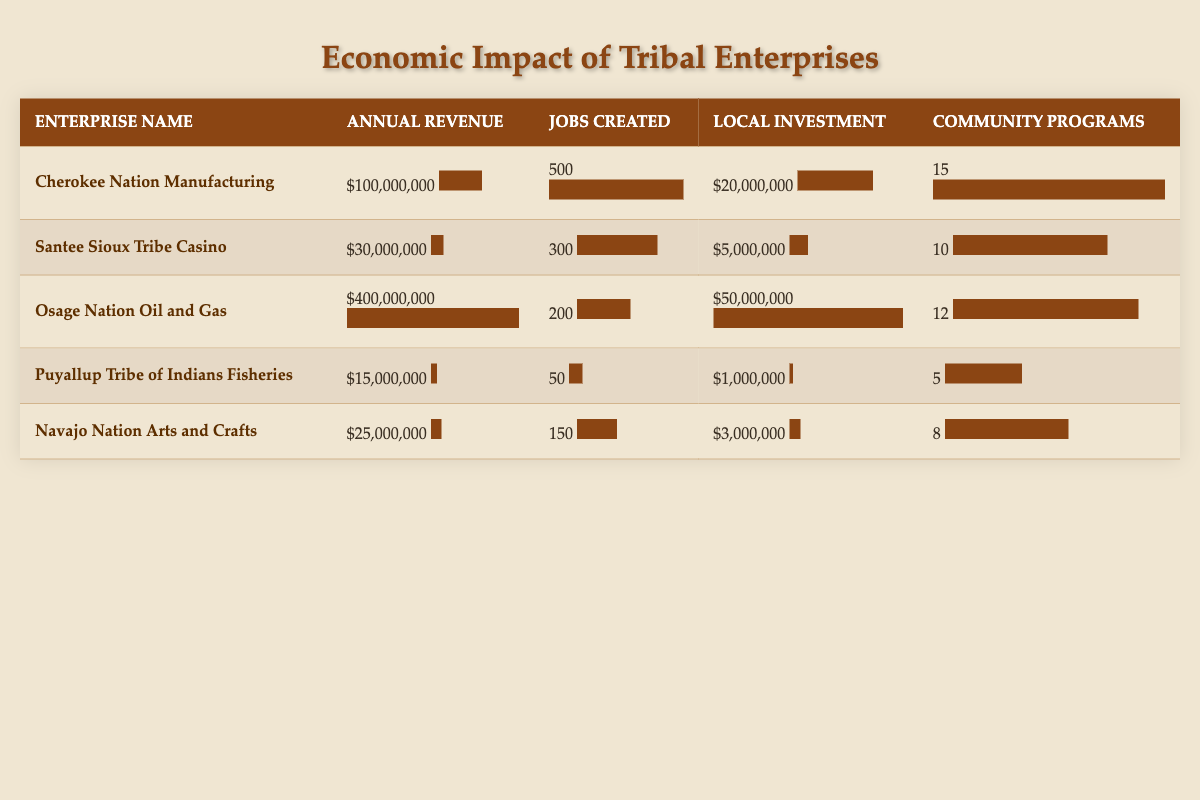What is the annual revenue of the Osage Nation Oil and Gas? The table shows that the annual revenue for the Osage Nation Oil and Gas is clearly listed as $400,000,000.
Answer: $400,000,000 How many jobs were created by the Cherokee Nation Manufacturing? Referring to the table, the number of jobs created by the Cherokee Nation Manufacturing is indicated as 500.
Answer: 500 Which tribal enterprise had the highest local investment? By examining the local investment values in the table, we see that the Osage Nation Oil and Gas has the highest local investment of $50,000,000.
Answer: Osage Nation Oil and Gas What is the total annual revenue generated by the Navajo Nation Arts and Crafts and the Puyallup Tribe of Indians Fisheries combined? To find the combined annual revenue, we add the annual revenues: $25,000,000 (Navajo Nation Arts and Crafts) + $15,000,000 (Puyallup Tribe of Indians Fisheries) = $40,000,000.
Answer: $40,000,000 Is the Santee Sioux Tribe Casino's community programs supported greater than the Puyallup Tribe of Indians Fisheries? In the table, Santee Sioux Tribe Casino supports 10 community programs while the Puyallup Tribe of Indians Fisheries supports only 5. Therefore, it is true that the Santee Sioux Tribe Casino supports more programs.
Answer: Yes What is the average number of jobs created across all enterprises? We sum the jobs created: 500 (Cherokee) + 300 (Santee Sioux) + 200 (Osage) + 50 (Puyallup) + 150 (Navajo) = 1200. Then, we divide by the total number of enterprises (5): 1200 / 5 = 240.
Answer: 240 Which enterprise has supported the fewest community programs? The table indicates that the Puyallup Tribe of Indians Fisheries has supported 5 community programs, which is the lowest number reported among the enterprises.
Answer: Puyallup Tribe of Indians Fisheries If the Osage Nation Oil and Gas was to reduce its jobs created by 50%, how many jobs would it then have? The original number of jobs created by Osage Nation Oil and Gas is 200. If we reduce this number by 50%, we calculate: 200 - (200 * 0.5) = 200 - 100 = 100.
Answer: 100 How many more community programs does the Cherokee Nation Manufacturing support compared to the Navajo Nation Arts and Crafts? The table shows that the Cherokee Nation Manufacturing supports 15 community programs while Navajo Nation Arts and Crafts supports 8. The difference is: 15 - 8 = 7.
Answer: 7 